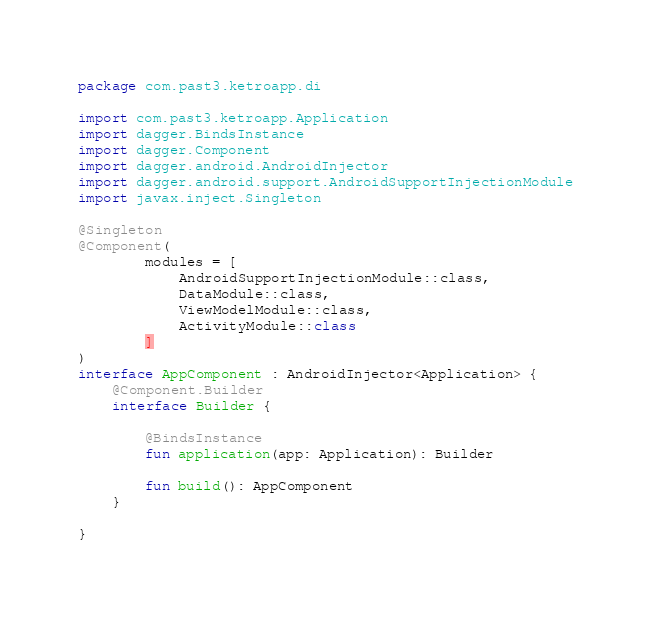Convert code to text. <code><loc_0><loc_0><loc_500><loc_500><_Kotlin_>package com.past3.ketroapp.di

import com.past3.ketroapp.Application
import dagger.BindsInstance
import dagger.Component
import dagger.android.AndroidInjector
import dagger.android.support.AndroidSupportInjectionModule
import javax.inject.Singleton

@Singleton
@Component(
        modules = [
            AndroidSupportInjectionModule::class,
            DataModule::class,
            ViewModelModule::class,
            ActivityModule::class
        ]
)
interface AppComponent : AndroidInjector<Application> {
    @Component.Builder
    interface Builder {

        @BindsInstance
        fun application(app: Application): Builder

        fun build(): AppComponent
    }

}
</code> 